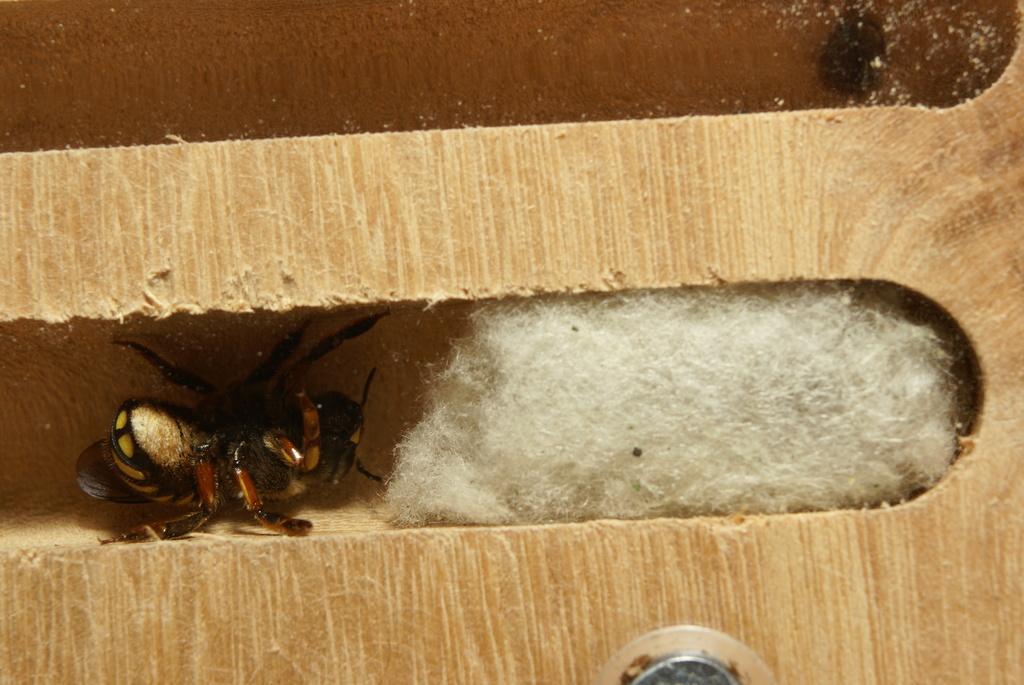Please provide a concise description of this image. In this image we can see an insect and cotton on a wooden plank and at the bottom we can see a screw kind of structure on the plank. 